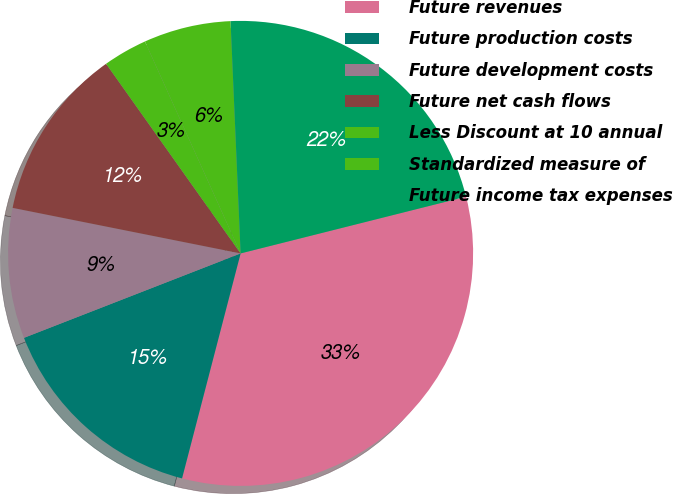Convert chart to OTSL. <chart><loc_0><loc_0><loc_500><loc_500><pie_chart><fcel>Future revenues<fcel>Future production costs<fcel>Future development costs<fcel>Future net cash flows<fcel>Less Discount at 10 annual<fcel>Standardized measure of<fcel>Future income tax expenses<nl><fcel>32.97%<fcel>15.03%<fcel>9.05%<fcel>12.04%<fcel>3.07%<fcel>6.06%<fcel>21.76%<nl></chart> 